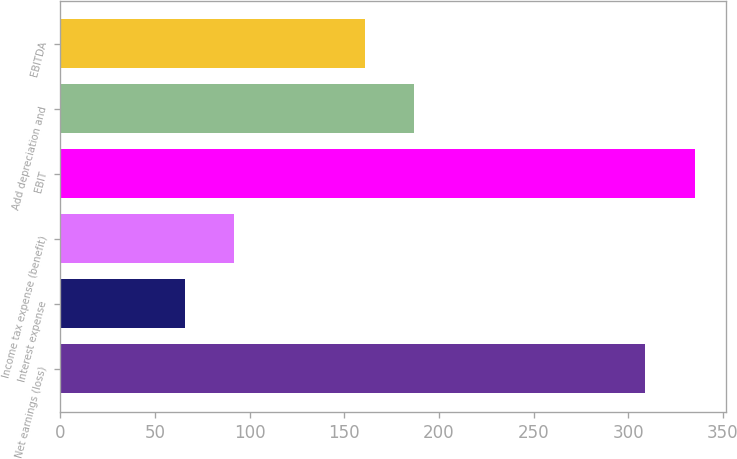Convert chart. <chart><loc_0><loc_0><loc_500><loc_500><bar_chart><fcel>Net earnings (loss)<fcel>Interest expense<fcel>Income tax expense (benefit)<fcel>EBIT<fcel>Add depreciation and<fcel>EBITDA<nl><fcel>309.1<fcel>65.9<fcel>91.91<fcel>335.11<fcel>187.01<fcel>161<nl></chart> 